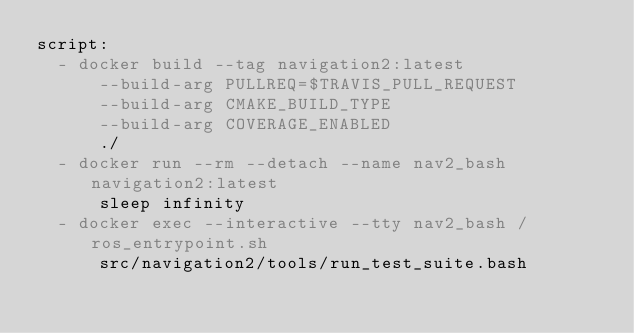Convert code to text. <code><loc_0><loc_0><loc_500><loc_500><_YAML_>script:
  - docker build --tag navigation2:latest
      --build-arg PULLREQ=$TRAVIS_PULL_REQUEST
      --build-arg CMAKE_BUILD_TYPE
      --build-arg COVERAGE_ENABLED
      ./
  - docker run --rm --detach --name nav2_bash navigation2:latest
      sleep infinity
  - docker exec --interactive --tty nav2_bash /ros_entrypoint.sh
      src/navigation2/tools/run_test_suite.bash
</code> 